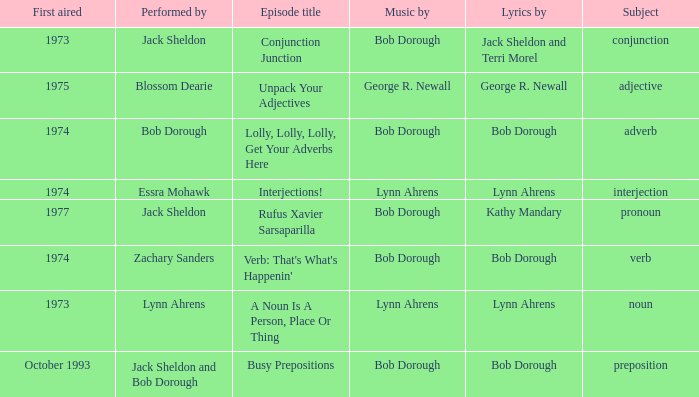When pronoun is the subject what is the episode title? Rufus Xavier Sarsaparilla. 